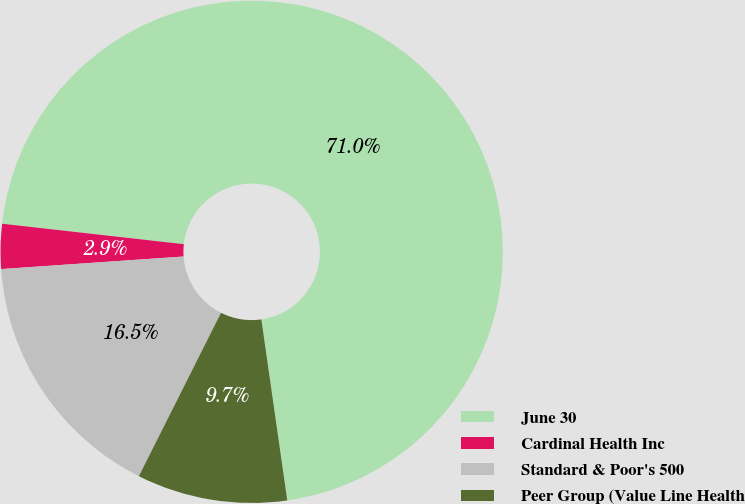<chart> <loc_0><loc_0><loc_500><loc_500><pie_chart><fcel>June 30<fcel>Cardinal Health Inc<fcel>Standard & Poor's 500<fcel>Peer Group (Value Line Health<nl><fcel>70.95%<fcel>2.88%<fcel>16.49%<fcel>9.68%<nl></chart> 